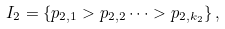<formula> <loc_0><loc_0><loc_500><loc_500>I _ { 2 } = \{ p _ { 2 , 1 } > p _ { 2 , 2 } \dots > p _ { 2 , k _ { 2 } } \} \, ,</formula> 